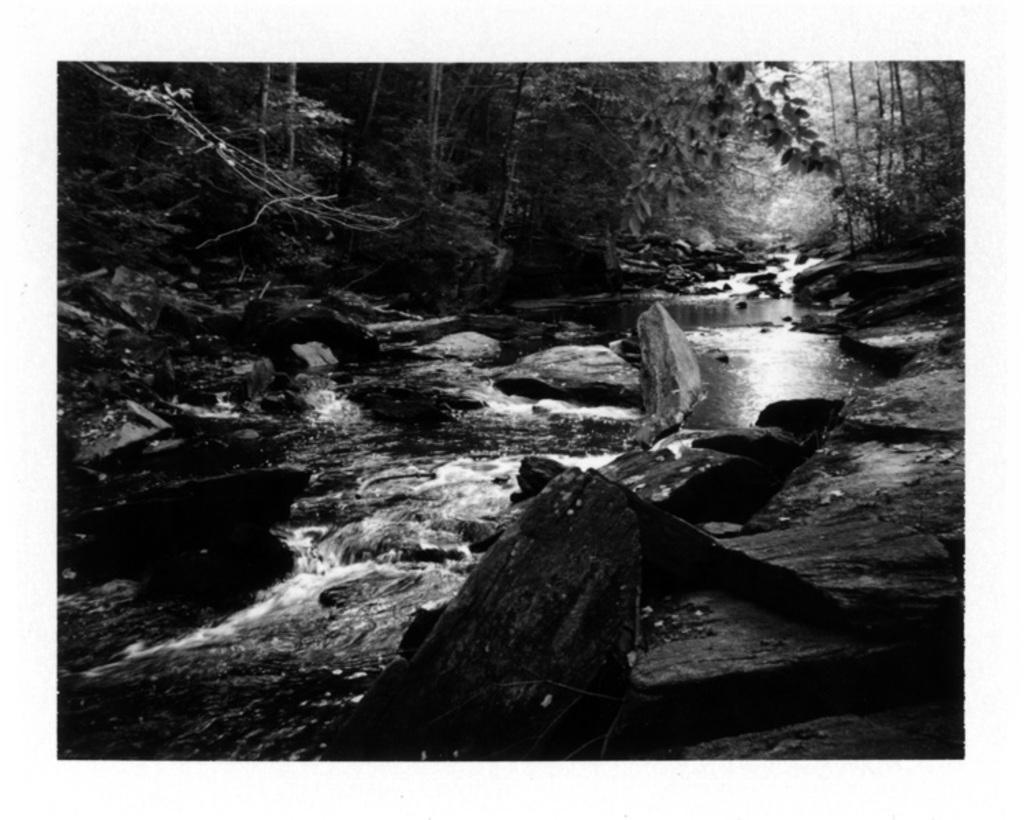What is the color scheme of the image? The image is black and white. What can be seen in the center of the image? There is water in the center of the image. What type of vegetation is visible in the background of the image? There are trees in the background of the image. What is located at the bottom of the image? There are rocks at the bottom of the image. What does the mind say in the caption of the image? There is no caption present in the image, and therefore no mind or caption can be observed. Additionally, the mind is not a visible object that can be seen in the image. 